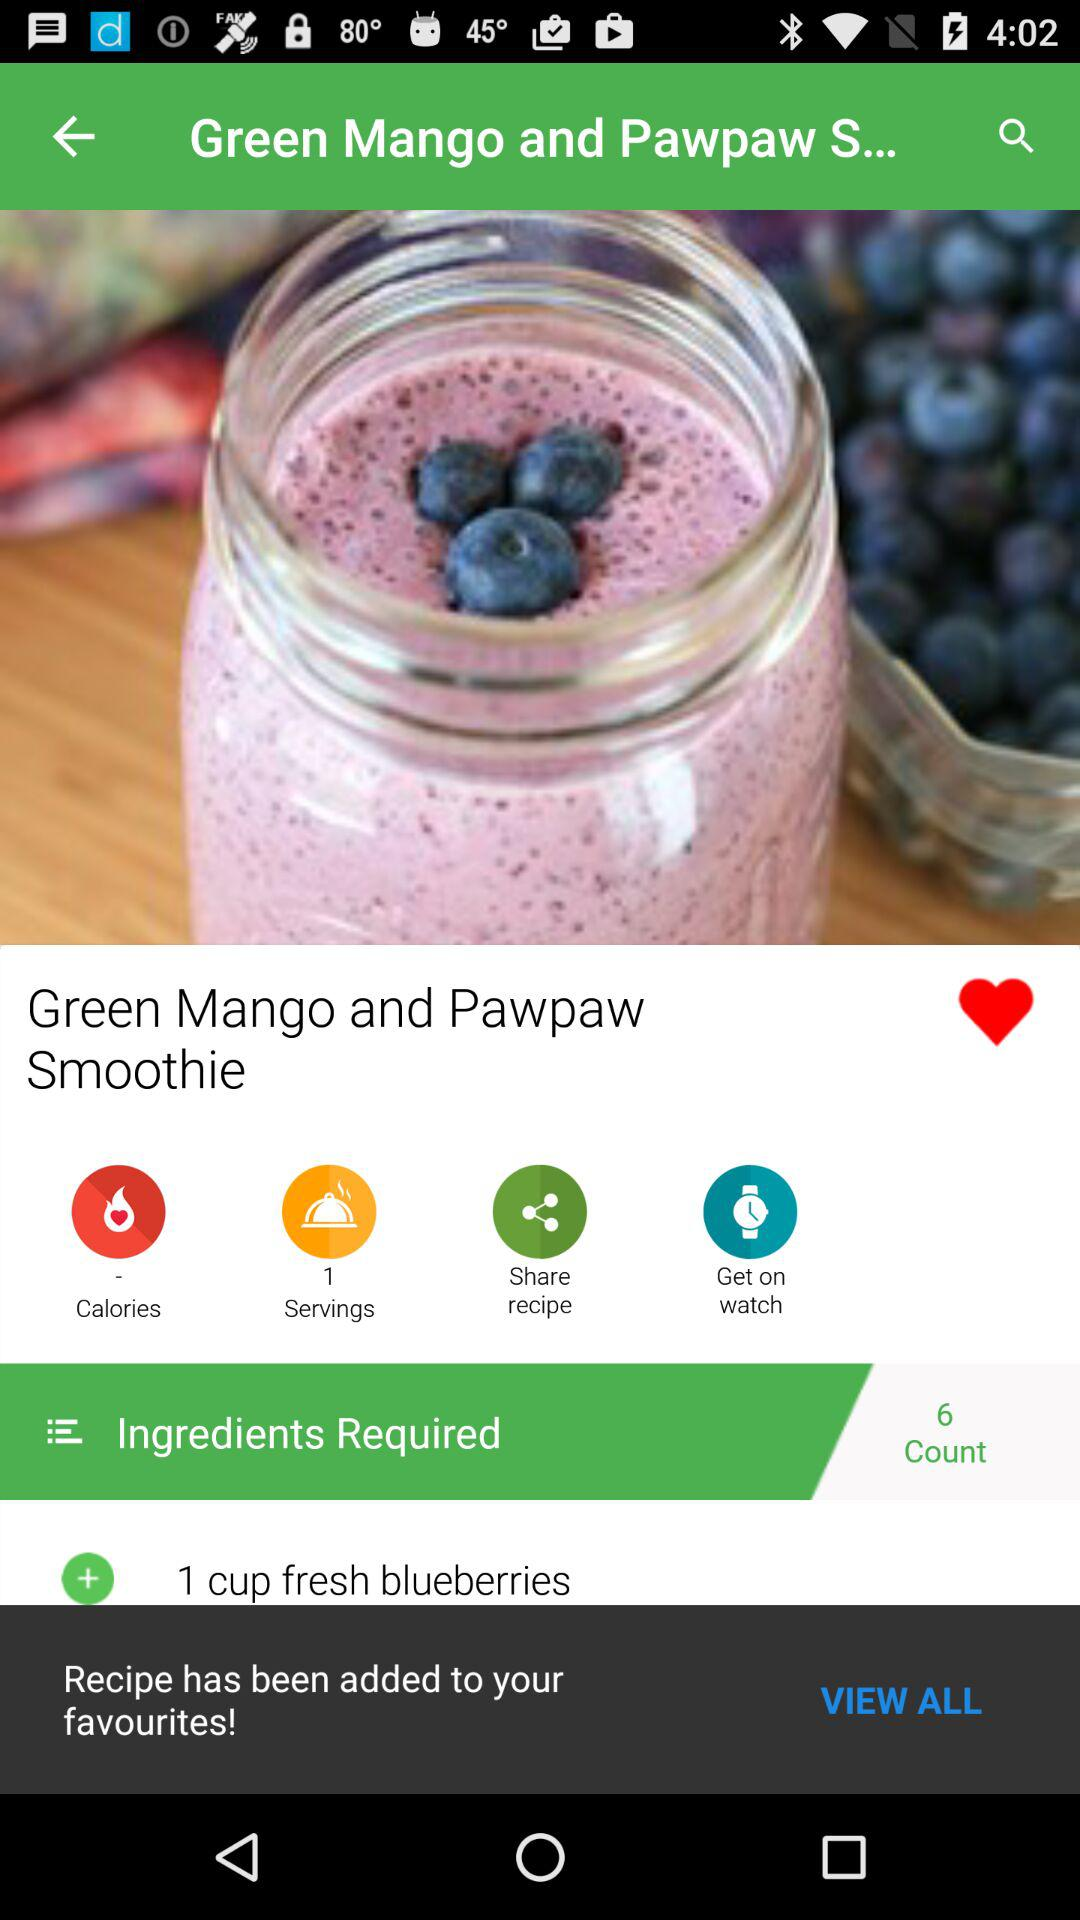What is the ingredient count shown on the screen? The ingredient count shown on the screen is 6. 